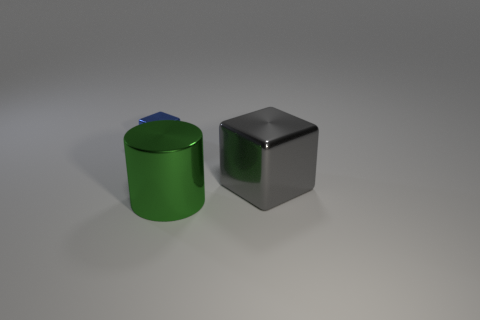Add 2 blue objects. How many objects exist? 5 Subtract all blocks. How many objects are left? 1 Subtract all green metallic things. Subtract all small cubes. How many objects are left? 1 Add 3 tiny blue shiny blocks. How many tiny blue shiny blocks are left? 4 Add 1 tiny things. How many tiny things exist? 2 Subtract 0 cyan blocks. How many objects are left? 3 